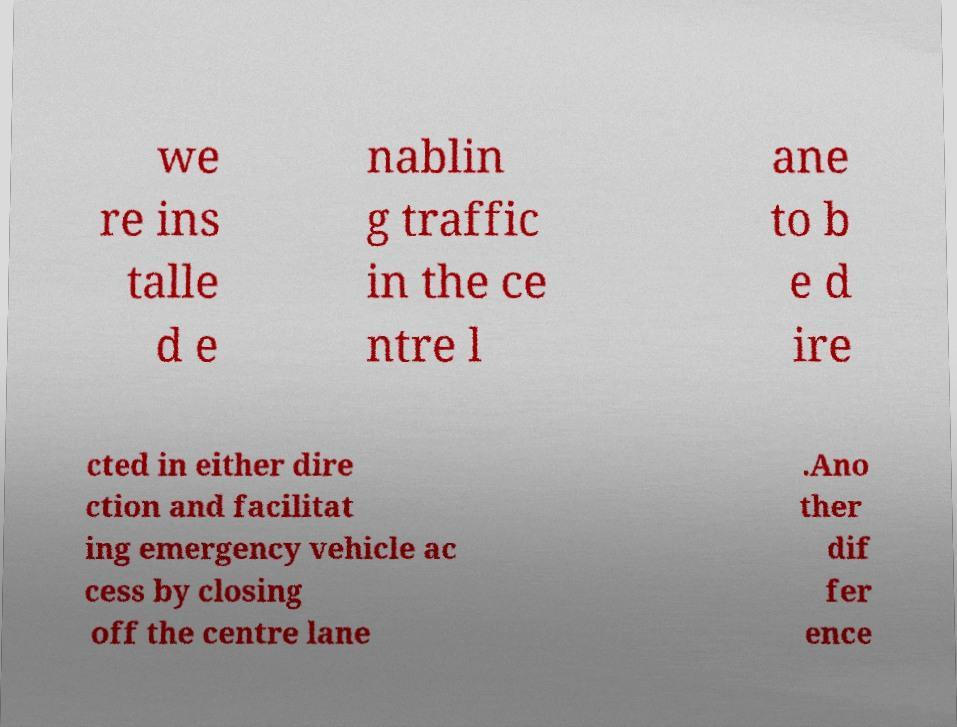For documentation purposes, I need the text within this image transcribed. Could you provide that? we re ins talle d e nablin g traffic in the ce ntre l ane to b e d ire cted in either dire ction and facilitat ing emergency vehicle ac cess by closing off the centre lane .Ano ther dif fer ence 